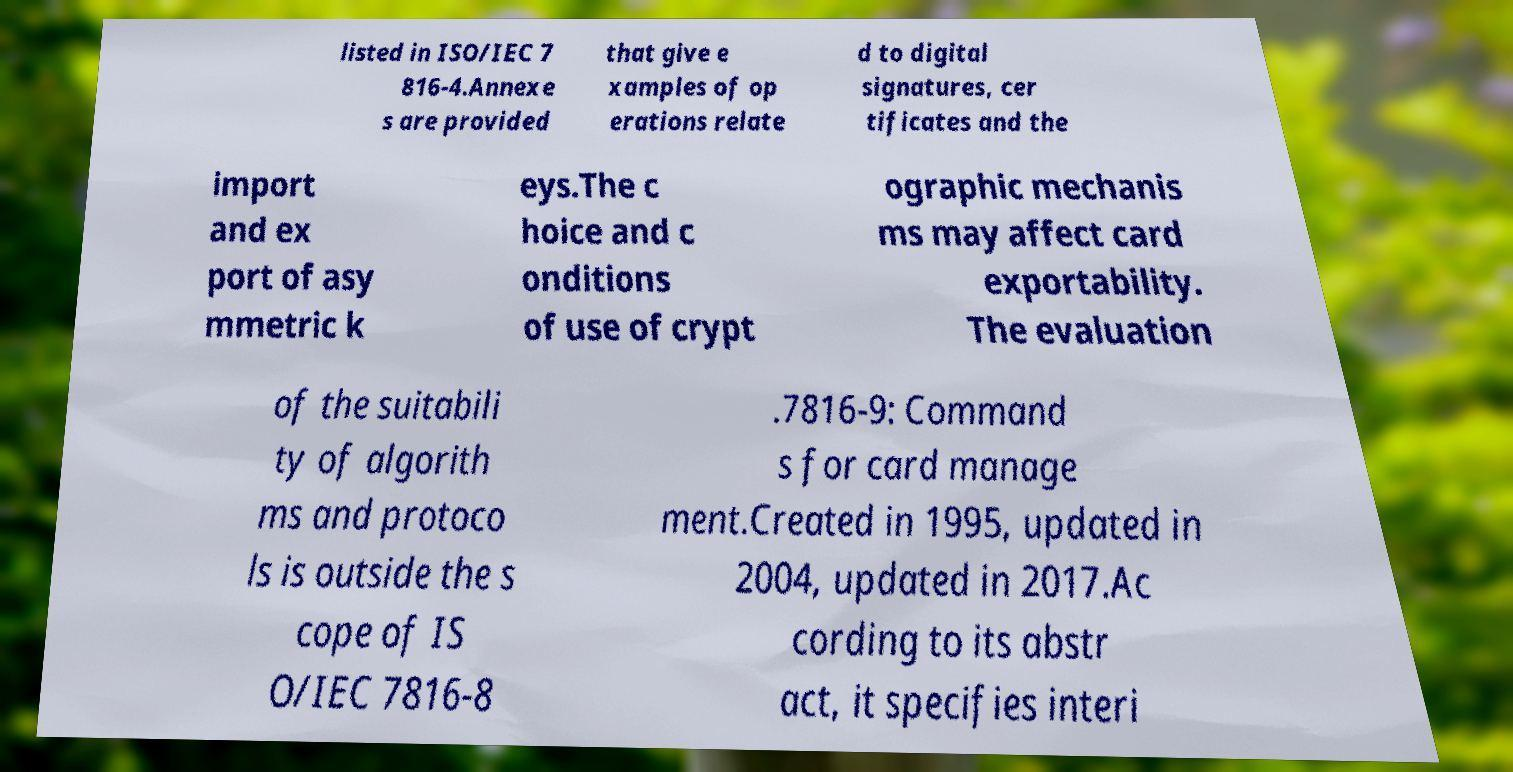Could you extract and type out the text from this image? listed in ISO/IEC 7 816-4.Annexe s are provided that give e xamples of op erations relate d to digital signatures, cer tificates and the import and ex port of asy mmetric k eys.The c hoice and c onditions of use of crypt ographic mechanis ms may affect card exportability. The evaluation of the suitabili ty of algorith ms and protoco ls is outside the s cope of IS O/IEC 7816-8 .7816-9: Command s for card manage ment.Created in 1995, updated in 2004, updated in 2017.Ac cording to its abstr act, it specifies interi 